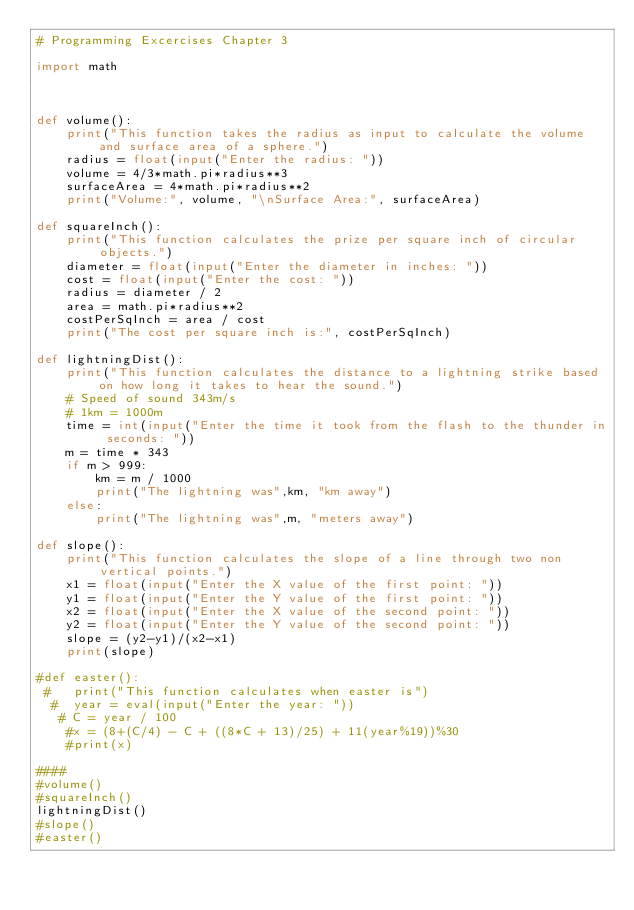<code> <loc_0><loc_0><loc_500><loc_500><_Python_># Programming Excercises Chapter 3

import math



def volume():
    print("This function takes the radius as input to calculate the volume and surface area of a sphere.")
    radius = float(input("Enter the radius: "))
    volume = 4/3*math.pi*radius**3
    surfaceArea = 4*math.pi*radius**2
    print("Volume:", volume, "\nSurface Area:", surfaceArea)

def squareInch():
    print("This function calculates the prize per square inch of circular objects.")
    diameter = float(input("Enter the diameter in inches: "))
    cost = float(input("Enter the cost: "))
    radius = diameter / 2
    area = math.pi*radius**2
    costPerSqInch = area / cost
    print("The cost per square inch is:", costPerSqInch)

def lightningDist():
    print("This function calculates the distance to a lightning strike based on how long it takes to hear the sound.")
    # Speed of sound 343m/s
    # 1km = 1000m
    time = int(input("Enter the time it took from the flash to the thunder in seconds: "))
    m = time * 343
    if m > 999:
        km = m / 1000
        print("The lightning was",km, "km away")
    else:
        print("The lightning was",m, "meters away")

def slope():
    print("This function calculates the slope of a line through two non vertical points.")
    x1 = float(input("Enter the X value of the first point: "))
    y1 = float(input("Enter the Y value of the first point: "))
    x2 = float(input("Enter the X value of the second point: "))
    y2 = float(input("Enter the Y value of the second point: "))
    slope = (y2-y1)/(x2-x1)
    print(slope)

#def easter():
 #   print("This function calculates when easter is")
  #  year = eval(input("Enter the year: "))
   # C = year / 100
    #x = (8+(C/4) - C + ((8*C + 13)/25) + 11(year%19))%30
    #print(x)

####
#volume()
#squareInch()
lightningDist()
#slope()
#easter()</code> 